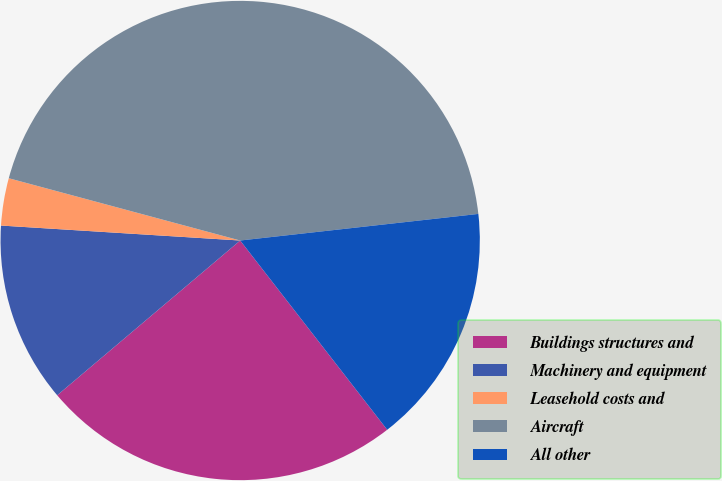<chart> <loc_0><loc_0><loc_500><loc_500><pie_chart><fcel>Buildings structures and<fcel>Machinery and equipment<fcel>Leasehold costs and<fcel>Aircraft<fcel>All other<nl><fcel>24.34%<fcel>12.17%<fcel>3.19%<fcel>44.05%<fcel>16.26%<nl></chart> 